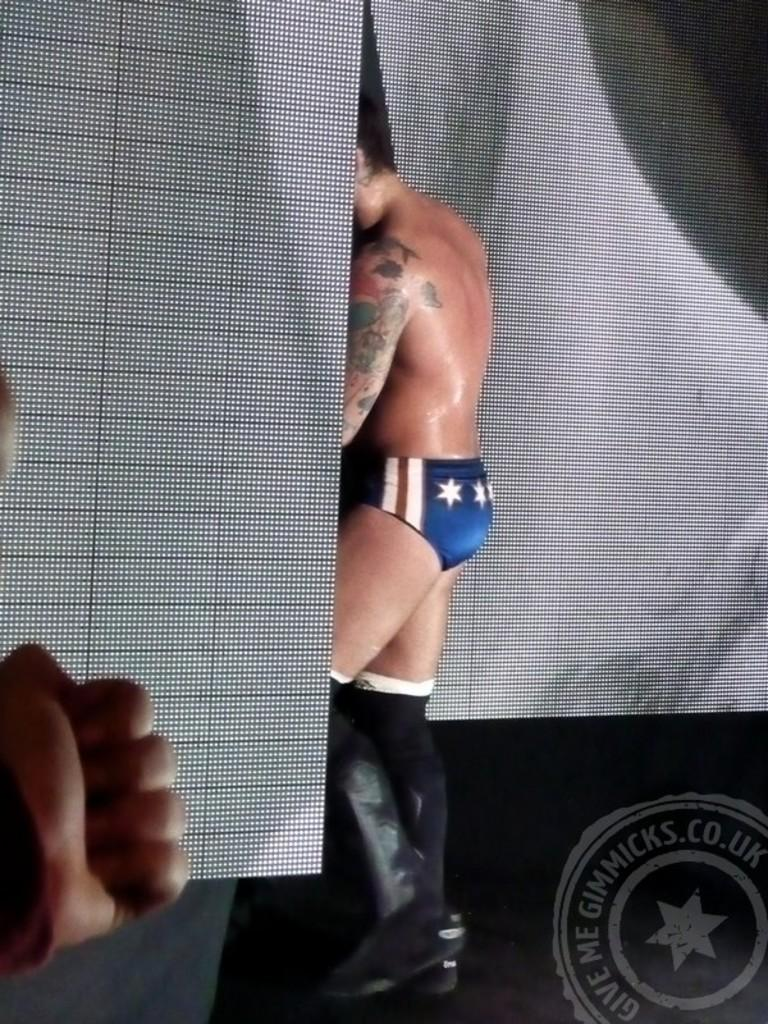What type of window treatment is present in the image? There are curtains in the image. Who or what can be seen standing in the image? A man is standing in the image. Where is the logo located in the image? The logo is in the right bottom of the image. What part of a person is visible on the left side of the image? A human hand is visible on the left side of the image. How many babies are crawling on the floor in the image? There are no babies present in the image. What is the man in the image thinking about? The image does not provide information about the man's thoughts or mental state. 